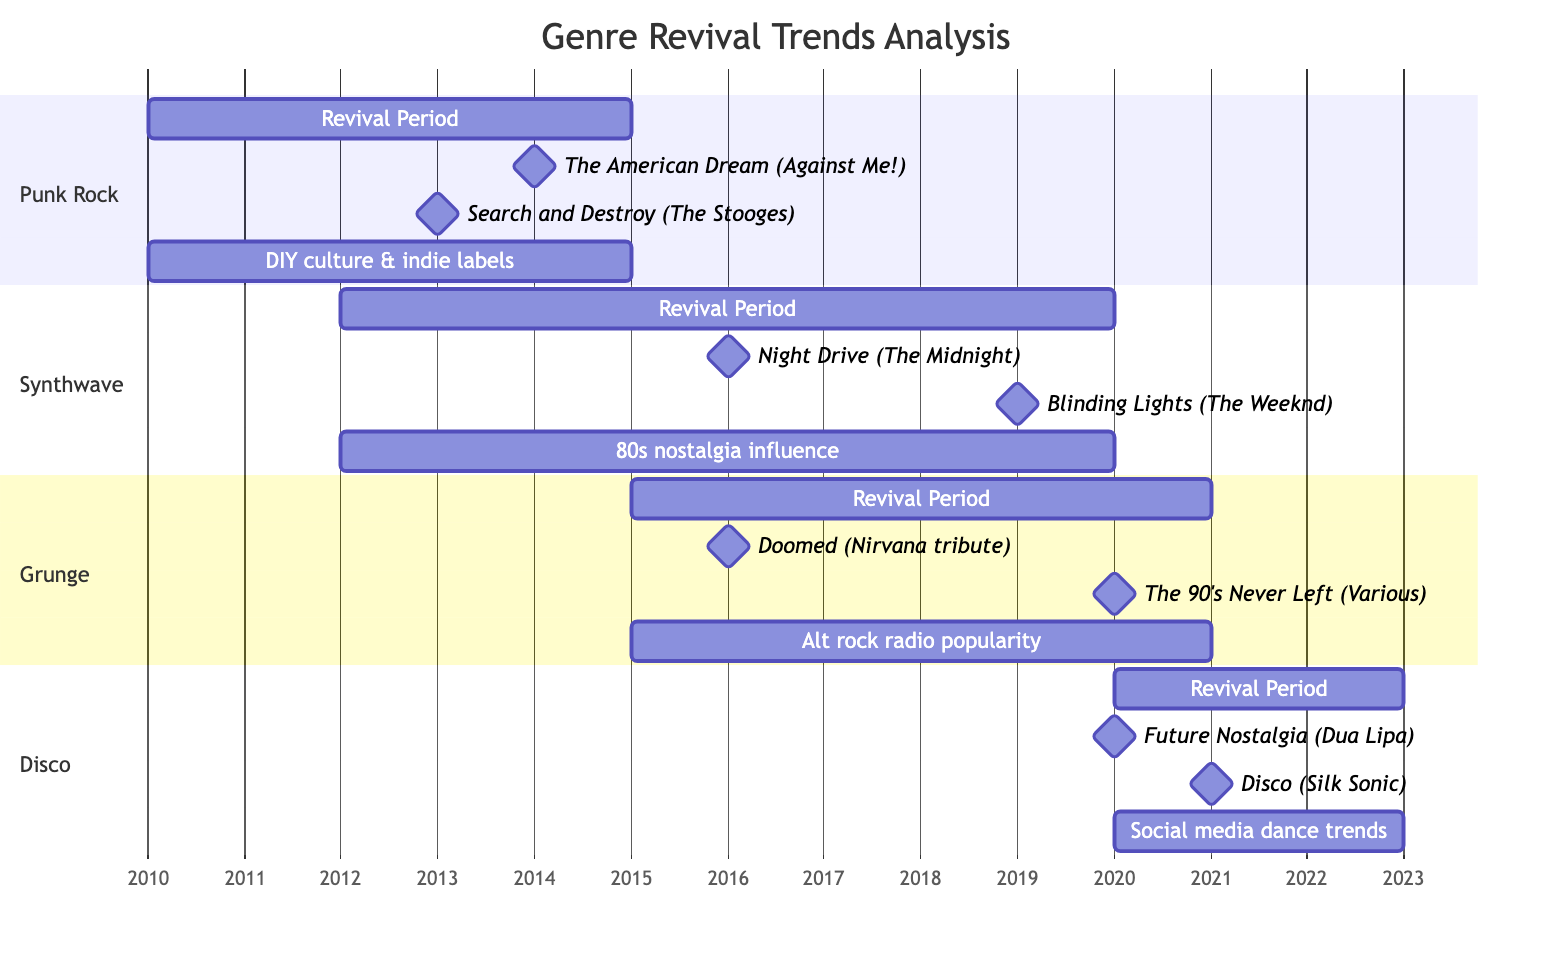What is the revival period for Punk Rock? The diagram clearly indicates the revival period as a bar representing the years 2010 to 2015 under the Punk Rock section.
Answer: 2010-2015 How many influential albums are listed for Synthwave? By examining the Synthwave section of the diagram, there are two albums mentioned as influential: "Night Drive" and "Blinding Lights."
Answer: 2 What major shift occurred in the industry during the Grunge revival? The Grunge section specifies the industry shift as "Increased popularity of alternative rock radio stations," which is linked to its revival period.
Answer: Increased popularity of alternative rock radio stations Which album by Bruno Mars relates to the Disco revival? Looking at the Disco section, "Disco" by Bruno Mars & Anderson .Paak (Silk Sonic) is mentioned as an influential album, clearly stated in the diagram.
Answer: Disco What year did the revival of Disco start? The Disco revival period starts in 2020, as shown in the respective section of the Gantt chart.
Answer: 2020 Which genre had its revival period overlapping with 2015? The diagram shows both Punk Rock (2010-2015) and Grunge (2015-2021) having revival periods that either start or end at 2015. Therefore, both genres overlap in that year.
Answer: Punk Rock, Grunge Which influential album in Synthwave was released in 2019? The diagram directly points to "Blinding Lights" by The Weeknd as the influential album from the Synthwave genre released in 2019.
Answer: Blinding Lights Is there a milestone for the Punk Rock revival in 2013? The diagram includes a milestone for "Search and Destroy" (The Stooges), which was released in 2013, confirming the presence of a milestone in that year.
Answer: Yes How many years did the revival of Synthwave last? The revival period spans from 2012 to 2020, calculated as 2020 - 2012, resulting in an 8-year period, as indicated by the bar length associated with this genre.
Answer: 8 years 